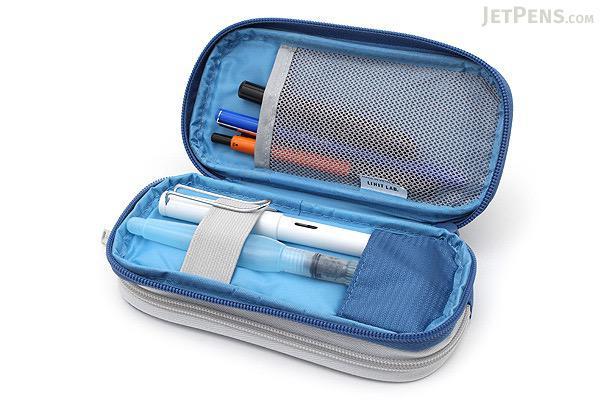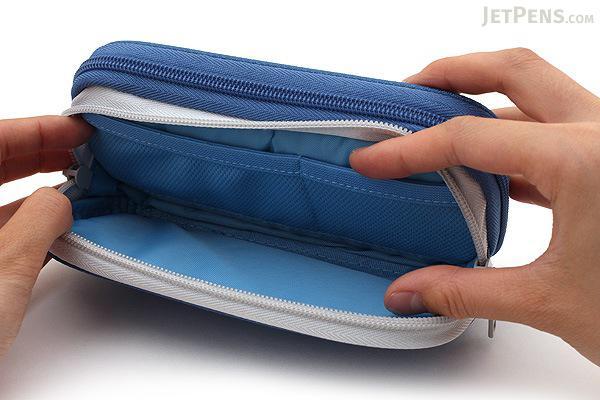The first image is the image on the left, the second image is the image on the right. Evaluate the accuracy of this statement regarding the images: "There is one yellow and one black case.". Is it true? Answer yes or no. No. The first image is the image on the left, the second image is the image on the right. Examine the images to the left and right. Is the description "Two blue cases are open, exposing the contents." accurate? Answer yes or no. Yes. The first image is the image on the left, the second image is the image on the right. Analyze the images presented: Is the assertion "An image shows a hand opening a blue pencil case." valid? Answer yes or no. Yes. The first image is the image on the left, the second image is the image on the right. Given the left and right images, does the statement "Each image includes a single pencil case, and the left image shows an open case filled with writing implements." hold true? Answer yes or no. Yes. 